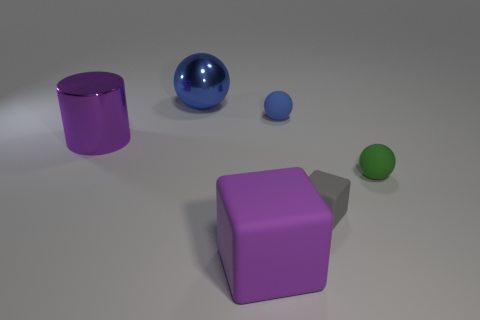Add 3 tiny brown metal cylinders. How many objects exist? 9 Subtract 1 cylinders. How many cylinders are left? 0 Subtract all green spheres. How many spheres are left? 2 Subtract all blocks. How many objects are left? 4 Subtract all green spheres. Subtract all brown cylinders. How many spheres are left? 2 Subtract all brown cubes. How many gray cylinders are left? 0 Subtract all large green matte cylinders. Subtract all gray cubes. How many objects are left? 5 Add 1 small blue balls. How many small blue balls are left? 2 Add 5 small matte balls. How many small matte balls exist? 7 Subtract all gray blocks. How many blocks are left? 1 